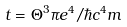<formula> <loc_0><loc_0><loc_500><loc_500>t = \Theta ^ { 3 } \pi e ^ { 4 } / \hbar { c } ^ { 4 } m</formula> 